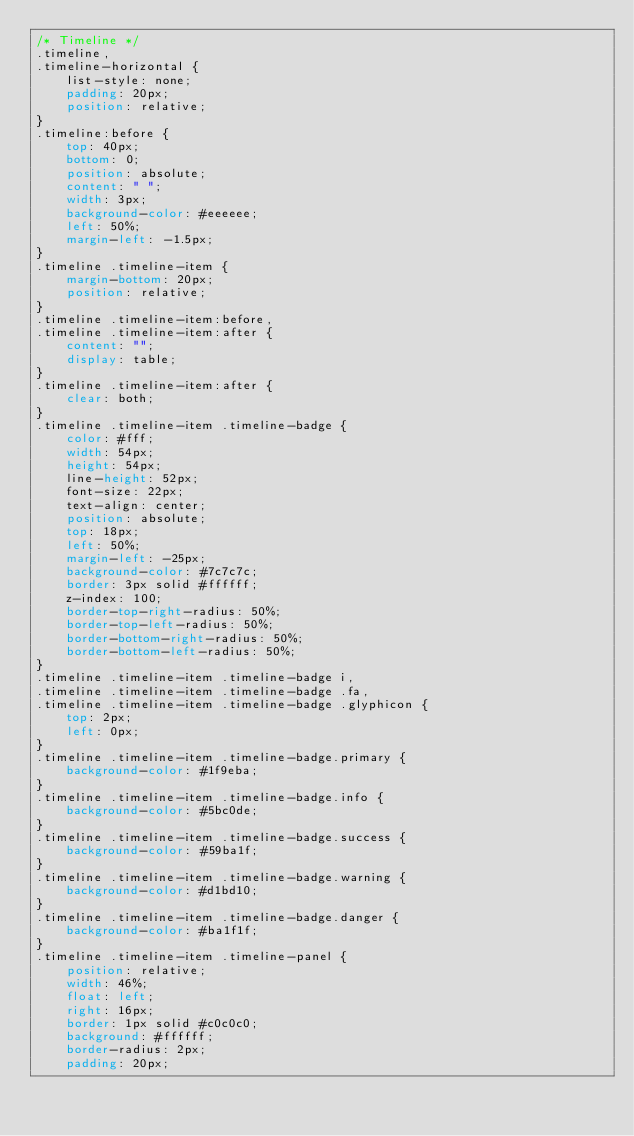Convert code to text. <code><loc_0><loc_0><loc_500><loc_500><_CSS_>/* Timeline */
.timeline,
.timeline-horizontal {
    list-style: none;
    padding: 20px;
    position: relative;
}
.timeline:before {
    top: 40px;
    bottom: 0;
    position: absolute;
    content: " ";
    width: 3px;
    background-color: #eeeeee;
    left: 50%;
    margin-left: -1.5px;
}
.timeline .timeline-item {
    margin-bottom: 20px;
    position: relative;
}
.timeline .timeline-item:before,
.timeline .timeline-item:after {
    content: "";
    display: table;
}
.timeline .timeline-item:after {
    clear: both;
}
.timeline .timeline-item .timeline-badge {
    color: #fff;
    width: 54px;
    height: 54px;
    line-height: 52px;
    font-size: 22px;
    text-align: center;
    position: absolute;
    top: 18px;
    left: 50%;
    margin-left: -25px;
    background-color: #7c7c7c;
    border: 3px solid #ffffff;
    z-index: 100;
    border-top-right-radius: 50%;
    border-top-left-radius: 50%;
    border-bottom-right-radius: 50%;
    border-bottom-left-radius: 50%;
}
.timeline .timeline-item .timeline-badge i,
.timeline .timeline-item .timeline-badge .fa,
.timeline .timeline-item .timeline-badge .glyphicon {
    top: 2px;
    left: 0px;
}
.timeline .timeline-item .timeline-badge.primary {
    background-color: #1f9eba;
}
.timeline .timeline-item .timeline-badge.info {
    background-color: #5bc0de;
}
.timeline .timeline-item .timeline-badge.success {
    background-color: #59ba1f;
}
.timeline .timeline-item .timeline-badge.warning {
    background-color: #d1bd10;
}
.timeline .timeline-item .timeline-badge.danger {
    background-color: #ba1f1f;
}
.timeline .timeline-item .timeline-panel {
    position: relative;
    width: 46%;
    float: left;
    right: 16px;
    border: 1px solid #c0c0c0;
    background: #ffffff;
    border-radius: 2px;
    padding: 20px;</code> 